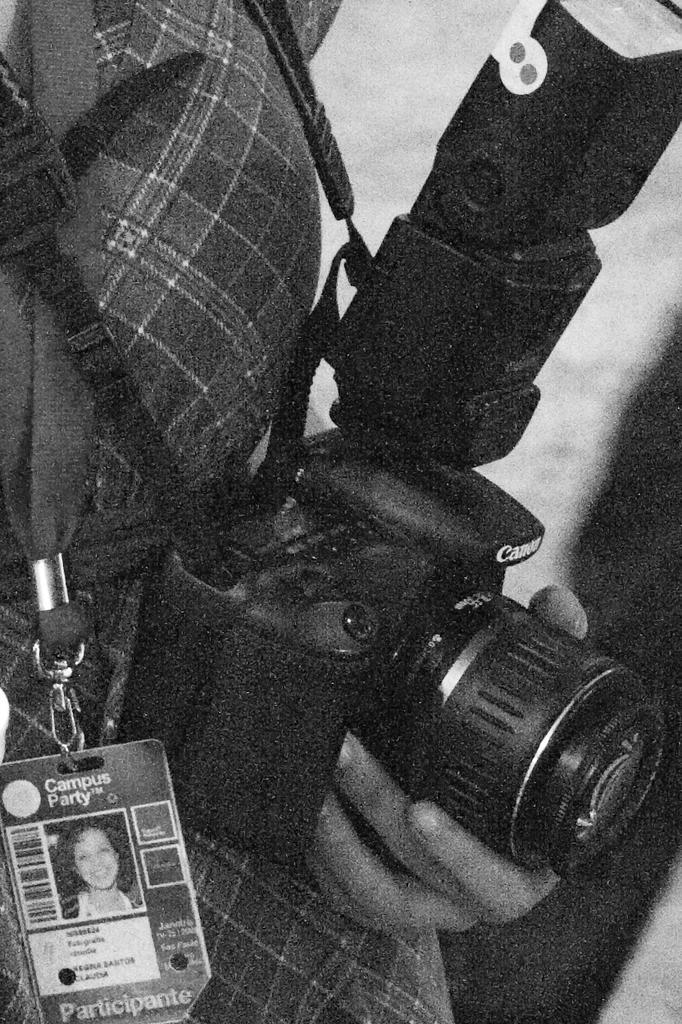In one or two sentences, can you explain what this image depicts? This is a black and white image. We can see the partially covered person holding a camera. We can also see an ID card. We can see the ground. 